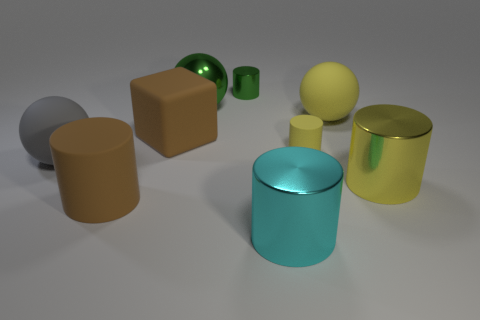Subtract 2 cylinders. How many cylinders are left? 3 Subtract all brown cylinders. Subtract all purple blocks. How many cylinders are left? 4 Add 1 gray metallic things. How many objects exist? 10 Subtract all blocks. How many objects are left? 8 Add 1 big yellow objects. How many big yellow objects are left? 3 Add 1 brown objects. How many brown objects exist? 3 Subtract 0 cyan balls. How many objects are left? 9 Subtract all large green shiny things. Subtract all large cubes. How many objects are left? 7 